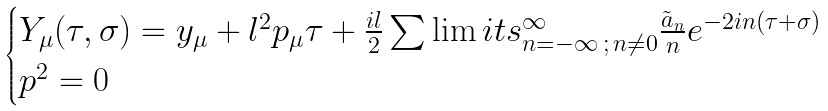Convert formula to latex. <formula><loc_0><loc_0><loc_500><loc_500>\begin{cases} Y _ { \mu } ( \tau , \sigma ) = y _ { \mu } + l ^ { 2 } p _ { \mu } \tau + \frac { i l } { 2 } \sum \lim i t s _ { n = - \infty \, ; \, n \neq 0 } ^ { \infty } \frac { { \tilde { a } } _ { n } } { n } e ^ { - 2 i n ( \tau + \sigma ) } \\ p ^ { 2 } = 0 \end{cases}</formula> 